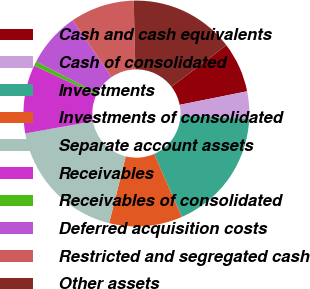Convert chart to OTSL. <chart><loc_0><loc_0><loc_500><loc_500><pie_chart><fcel>Cash and cash equivalents<fcel>Cash of consolidated<fcel>Investments<fcel>Investments of consolidated<fcel>Separate account assets<fcel>Receivables<fcel>Receivables of consolidated<fcel>Deferred acquisition costs<fcel>Restricted and segregated cash<fcel>Other assets<nl><fcel>7.19%<fcel>3.92%<fcel>17.65%<fcel>10.46%<fcel>18.3%<fcel>9.8%<fcel>0.65%<fcel>7.84%<fcel>9.15%<fcel>15.03%<nl></chart> 